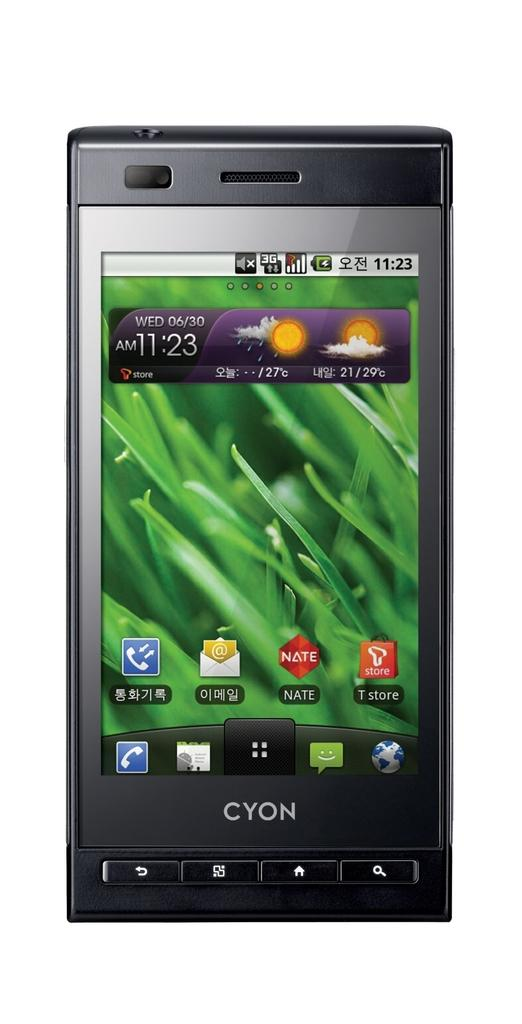<image>
Provide a brief description of the given image. A Cyon phone screen says it is 11:23 AM on Wednesday, June 30th. 